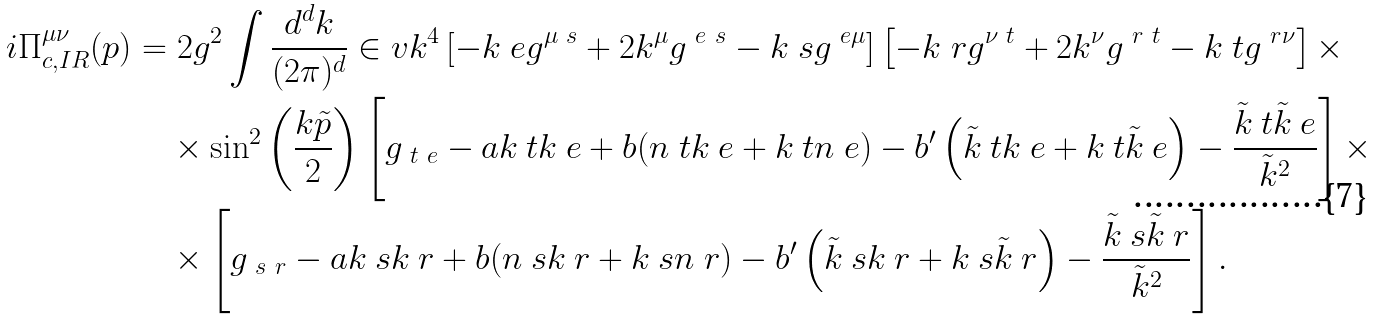<formula> <loc_0><loc_0><loc_500><loc_500>i \Pi ^ { \mu \nu } _ { c , I R } ( p ) & = 2 g ^ { 2 } \int \frac { d ^ { d } k } { ( 2 \pi ) ^ { d } } \in v { k ^ { 4 } } \left [ - k ^ { \ } e g ^ { \mu \ s } + 2 k ^ { \mu } g ^ { \ e \ s } - k ^ { \ } s g ^ { \ e \mu } \right ] \left [ - k ^ { \ } r g ^ { \nu \ t } + 2 k ^ { \nu } g ^ { \ r \ t } - k ^ { \ } t g ^ { \ r \nu } \right ] \times \\ & \quad \times \sin ^ { 2 } \left ( \frac { k \tilde { p } } { 2 } \right ) \left [ g _ { \ t \ e } - a k _ { \ } t k _ { \ } e + b ( n _ { \ } t k _ { \ } e + k _ { \ } t n _ { \ } e ) - b ^ { \prime } \left ( \tilde { k } _ { \ } t k _ { \ } e + k _ { \ } t \tilde { k } _ { \ } e \right ) - \frac { \tilde { k } _ { \ } t \tilde { k } _ { \ } e } { \tilde { k } ^ { 2 } } \right ] \times \\ & \quad \times \left [ g _ { \ s \ r } - a k _ { \ } s k _ { \ } r + b ( n _ { \ } s k _ { \ } r + k _ { \ } s n _ { \ } r ) - b ^ { \prime } \left ( \tilde { k } _ { \ } s k _ { \ } r + k _ { \ } s \tilde { k } _ { \ } r \right ) - \frac { \tilde { k } _ { \ } s \tilde { k } _ { \ } r } { \tilde { k } ^ { 2 } } \right ] .</formula> 